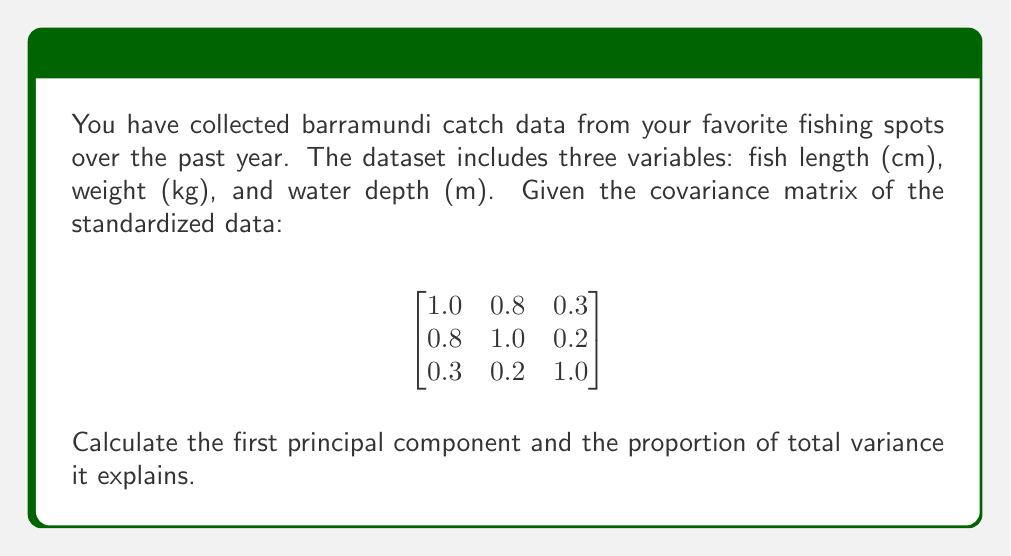Help me with this question. To find the principal components and their explained variance, we need to perform eigendecomposition on the covariance matrix.

Step 1: Calculate the eigenvalues (λ) and eigenvectors (v) of the covariance matrix.
Using a computer or calculator, we find:

λ₁ ≈ 1.8917
v₁ ≈ [0.6404, 0.6115, 0.4646]

λ₂ ≈ 0.9799
v₂ ≈ [-0.2947, -0.1897, 0.8857]

λ₃ ≈ 0.1284
v₃ ≈ [0.7088, -0.7682, 0.0005]

Step 2: The first principal component is the eigenvector corresponding to the largest eigenvalue (λ₁).
PC1 = [0.6404, 0.6115, 0.4646]

Step 3: Calculate the total variance.
Total variance = sum of eigenvalues = 1.8917 + 0.9799 + 0.1284 = 3

Step 4: Calculate the proportion of variance explained by the first principal component.
Proportion = λ₁ / Total variance = 1.8917 / 3 ≈ 0.6306 or 63.06%
Answer: PC1 = [0.6404, 0.6115, 0.4646]; Explained variance = 63.06% 